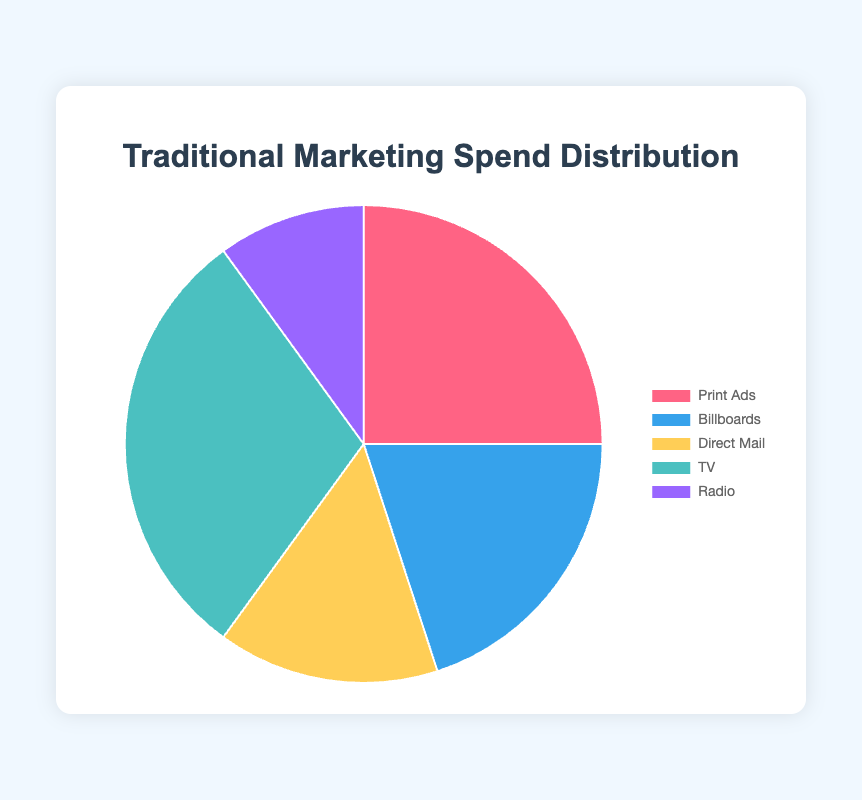Which marketing category has the largest spend percentage? To determine the category with the largest spend percentage, we look for the section with the highest percentage figure. From the data, TV has the highest spend percentage of 30%.
Answer: TV Which marketing category has the smallest spend percentage? To find the category with the smallest spend percentage, we identify the section with the lowest percentage. According to the data, Radio has the smallest percentage at 10%.
Answer: Radio What is the combined percentage of Print Ads and Billboards? To find the combined percentage, add the percentages for Print Ads and Billboards. Print Ads is 25% and Billboards is 20%. Thus, 25% + 20% = 45%.
Answer: 45% Which marketing categories together constitute half (50%) of the total spend? We need to find categories whose combined percentages add up to 50%. Adding the highest values first, TV (30%) and Print Ads (25%) exceed 50%. Checking smaller combinations, Print Ads (25%) and Billboards (20%) together equal 45%, requiring an additional 5% from Direct Mail's 15%, summing 60% (still not 50%). Hence, no exact half can be made strictly from two categories. Therefore, the best combination forming close to half is Print Ads and Billboards equaling 45% which is the nearest below 50%.
Answer: Print Ads and Billboards By what percentage does the TV spend exceed Radio spend? To find the difference in spend percentage between TV and Radio, subtract Radio's percentage from TV's. TV is 30% and Radio is 10%, so 30% - 10% = 20%.
Answer: 20% What is the average spend percentage across all categories? The average percentage is calculated by summing all data percentages and dividing by the number of categories. Adding all: 25% + 20% + 15% + 30% + 10% = 100%. Given there are 5 categories, the average is 100% / 5 = 20%.
Answer: 20% Which category’s segment is represented by the blue color? By observing the color assigned to each section in the chart, the blue color segment corresponds to Billboards.
Answer: Billboards What is the ratio of spend between Print Ads and Radio? To find the ratio of spend between Print Ads and Radio, divide Print Ads percentage by Radio percentage. Print Ads is 25% and Radio is 10%, thus 25% / 10% = 2.5. The ratio is therefore 2.5:1.
Answer: 2.5:1 